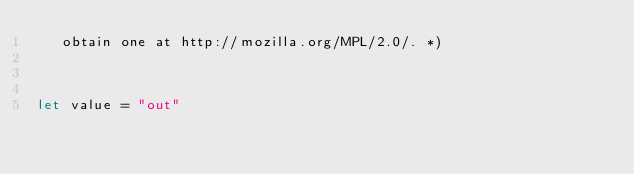Convert code to text. <code><loc_0><loc_0><loc_500><loc_500><_OCaml_>   obtain one at http://mozilla.org/MPL/2.0/. *)



let value = "out"
</code> 